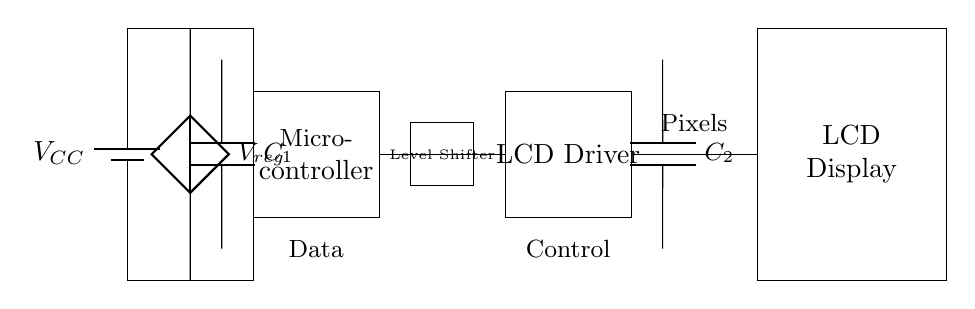What is the main power source in this circuit? The main power source is the battery labeled VCC, which provides the necessary voltage to the circuit.
Answer: VCC What component regulates the voltage in this circuit? The voltage regulator, indicated with the label Vreg, is responsible for maintaining a consistent output voltage from the power source.
Answer: Voltage Regulator What is the function of the Level Shifter? The Level Shifter is used to translate voltage levels between the microcontroller and the LCD driver, ensuring compatible signal levels for communication.
Answer: Translate voltage levels How many capacitors are present in the circuit? There are two capacitors labeled C1 and C2, one connected to the voltage regulator and another to the LCD driver.
Answer: Two Which component directly connects the LCD driver to the LCD display? The LCD driver is directly connected to the LCD display through the labeled Pixels line, allowing the driver to control the display's output.
Answer: LCD Driver What type of display is being driven in this circuit? The circuit is designed to drive an LCD display, specifically a low-power type suitable for portable applications like teleprompters.
Answer: LCD Display How does the microcontroller communicate with the LCD driver? The microcontroller communicates with the LCD driver through a dedicated Control line, allowing it to send commands and data for display management.
Answer: Control line 